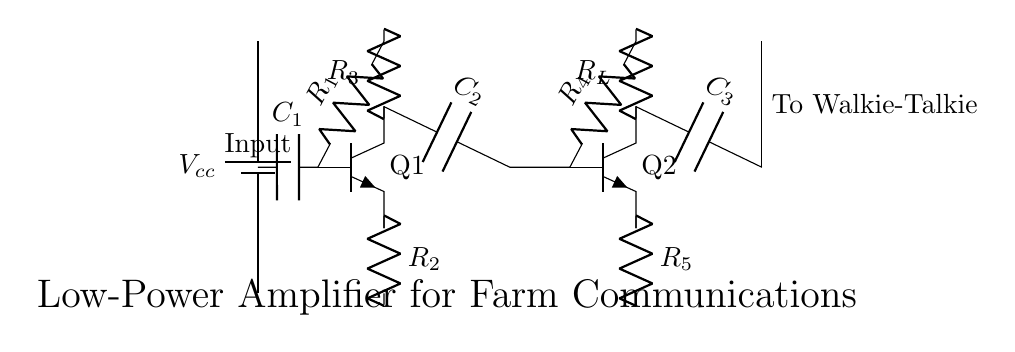What is the type of amplifier shown in the circuit? The circuit is a low-power amplifier as indicated by its label and design purpose of extending communication range.
Answer: Low-power amplifier What component is used for coupling in this circuit? The coupling between stages is achieved using capacitors, specifically labeled as C2 and C3.
Answer: Capacitors How many resistors are in the output stage of the amplifier? There are two resistors in the output stage, labeled as R4 and R5.
Answer: Two What is the role of capacitor C1 in the circuit? Capacitor C1 is connected to the base of transistor Q1, and it acts to couple the signal while blocking any DC component, allowing only AC signals to pass.
Answer: Coupling capacitor What is the voltage supply for this circuit? The voltage supply for the circuit is labeled as Vcc, which is indicated at the battery symbol at the top left.
Answer: Vcc How are the transistors connected in the amplifier circuit? The transistors Q1 and Q2 are connected in a common-emitter configuration, which is typical for signal amplification, with feedback through the resistors.
Answer: Common-emitter configuration What is the purpose of the load resistor R_L in the circuit? The load resistor R_L is connected to the collector of Q2 and is used to develop the output signal, determining the output voltage swing and gain of the amplifier.
Answer: Develop output signal 